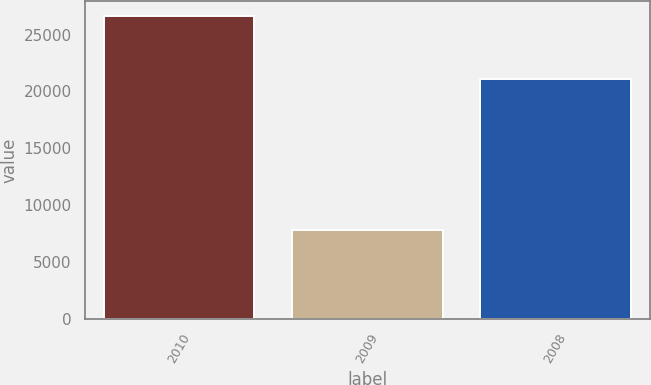<chart> <loc_0><loc_0><loc_500><loc_500><bar_chart><fcel>2010<fcel>2009<fcel>2008<nl><fcel>26624.8<fcel>7825<fcel>21064.7<nl></chart> 